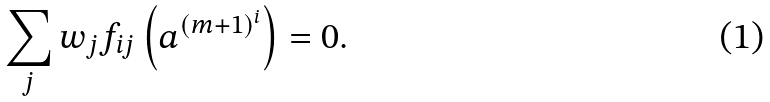Convert formula to latex. <formula><loc_0><loc_0><loc_500><loc_500>\sum _ { j } w _ { j } f _ { i j } \left ( a ^ { ( m + 1 ) ^ { i } } \right ) = 0 .</formula> 